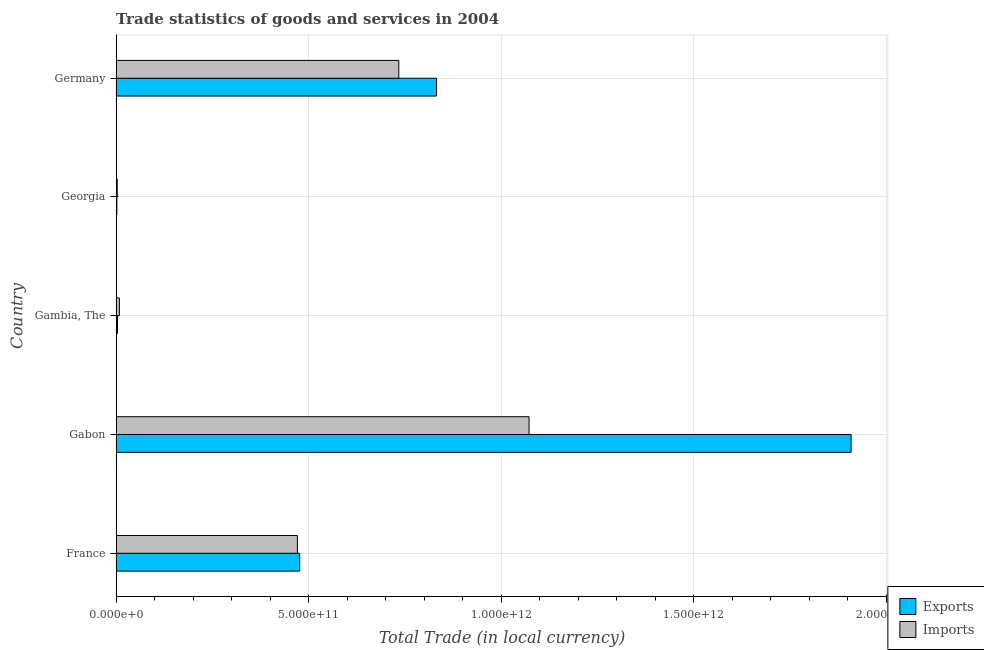Are the number of bars per tick equal to the number of legend labels?
Ensure brevity in your answer.  Yes. What is the label of the 2nd group of bars from the top?
Your answer should be very brief. Georgia. What is the imports of goods and services in Gambia, The?
Your answer should be very brief. 8.47e+09. Across all countries, what is the maximum imports of goods and services?
Offer a terse response. 1.07e+12. Across all countries, what is the minimum imports of goods and services?
Make the answer very short. 2.89e+09. In which country was the export of goods and services maximum?
Offer a terse response. Gabon. In which country was the imports of goods and services minimum?
Provide a succinct answer. Georgia. What is the total export of goods and services in the graph?
Your response must be concise. 3.22e+12. What is the difference between the export of goods and services in Georgia and that in Germany?
Provide a short and direct response. -8.30e+11. What is the difference between the imports of goods and services in Germany and the export of goods and services in France?
Make the answer very short. 2.57e+11. What is the average export of goods and services per country?
Ensure brevity in your answer.  6.44e+11. What is the difference between the imports of goods and services and export of goods and services in France?
Make the answer very short. -6.03e+09. What is the ratio of the export of goods and services in Gabon to that in Georgia?
Make the answer very short. 1007.66. Is the export of goods and services in Gabon less than that in Gambia, The?
Make the answer very short. No. What is the difference between the highest and the second highest export of goods and services?
Ensure brevity in your answer.  1.08e+12. What is the difference between the highest and the lowest export of goods and services?
Your response must be concise. 1.91e+12. What does the 1st bar from the top in France represents?
Your answer should be compact. Imports. What does the 1st bar from the bottom in Gambia, The represents?
Offer a very short reply. Exports. Are all the bars in the graph horizontal?
Provide a short and direct response. Yes. How many countries are there in the graph?
Make the answer very short. 5. What is the difference between two consecutive major ticks on the X-axis?
Provide a succinct answer. 5.00e+11. Does the graph contain any zero values?
Ensure brevity in your answer.  No. Where does the legend appear in the graph?
Give a very brief answer. Bottom right. How many legend labels are there?
Keep it short and to the point. 2. What is the title of the graph?
Keep it short and to the point. Trade statistics of goods and services in 2004. What is the label or title of the X-axis?
Your answer should be compact. Total Trade (in local currency). What is the Total Trade (in local currency) in Exports in France?
Ensure brevity in your answer.  4.77e+11. What is the Total Trade (in local currency) in Imports in France?
Keep it short and to the point. 4.71e+11. What is the Total Trade (in local currency) in Exports in Gabon?
Offer a terse response. 1.91e+12. What is the Total Trade (in local currency) of Imports in Gabon?
Keep it short and to the point. 1.07e+12. What is the Total Trade (in local currency) in Exports in Gambia, The?
Provide a succinct answer. 3.53e+09. What is the Total Trade (in local currency) in Imports in Gambia, The?
Provide a short and direct response. 8.47e+09. What is the Total Trade (in local currency) in Exports in Georgia?
Give a very brief answer. 1.89e+09. What is the Total Trade (in local currency) of Imports in Georgia?
Ensure brevity in your answer.  2.89e+09. What is the Total Trade (in local currency) of Exports in Germany?
Give a very brief answer. 8.32e+11. What is the Total Trade (in local currency) of Imports in Germany?
Provide a succinct answer. 7.34e+11. Across all countries, what is the maximum Total Trade (in local currency) of Exports?
Offer a terse response. 1.91e+12. Across all countries, what is the maximum Total Trade (in local currency) in Imports?
Your response must be concise. 1.07e+12. Across all countries, what is the minimum Total Trade (in local currency) of Exports?
Make the answer very short. 1.89e+09. Across all countries, what is the minimum Total Trade (in local currency) in Imports?
Your answer should be compact. 2.89e+09. What is the total Total Trade (in local currency) of Exports in the graph?
Keep it short and to the point. 3.22e+12. What is the total Total Trade (in local currency) of Imports in the graph?
Ensure brevity in your answer.  2.29e+12. What is the difference between the Total Trade (in local currency) in Exports in France and that in Gabon?
Your answer should be very brief. -1.43e+12. What is the difference between the Total Trade (in local currency) in Imports in France and that in Gabon?
Offer a terse response. -6.02e+11. What is the difference between the Total Trade (in local currency) of Exports in France and that in Gambia, The?
Your response must be concise. 4.73e+11. What is the difference between the Total Trade (in local currency) of Imports in France and that in Gambia, The?
Provide a succinct answer. 4.62e+11. What is the difference between the Total Trade (in local currency) of Exports in France and that in Georgia?
Your answer should be very brief. 4.75e+11. What is the difference between the Total Trade (in local currency) in Imports in France and that in Georgia?
Your response must be concise. 4.68e+11. What is the difference between the Total Trade (in local currency) of Exports in France and that in Germany?
Provide a short and direct response. -3.55e+11. What is the difference between the Total Trade (in local currency) of Imports in France and that in Germany?
Keep it short and to the point. -2.63e+11. What is the difference between the Total Trade (in local currency) of Exports in Gabon and that in Gambia, The?
Your response must be concise. 1.90e+12. What is the difference between the Total Trade (in local currency) of Imports in Gabon and that in Gambia, The?
Your response must be concise. 1.06e+12. What is the difference between the Total Trade (in local currency) in Exports in Gabon and that in Georgia?
Your answer should be very brief. 1.91e+12. What is the difference between the Total Trade (in local currency) of Imports in Gabon and that in Georgia?
Keep it short and to the point. 1.07e+12. What is the difference between the Total Trade (in local currency) of Exports in Gabon and that in Germany?
Your answer should be compact. 1.08e+12. What is the difference between the Total Trade (in local currency) in Imports in Gabon and that in Germany?
Ensure brevity in your answer.  3.38e+11. What is the difference between the Total Trade (in local currency) in Exports in Gambia, The and that in Georgia?
Provide a short and direct response. 1.64e+09. What is the difference between the Total Trade (in local currency) of Imports in Gambia, The and that in Georgia?
Your response must be concise. 5.58e+09. What is the difference between the Total Trade (in local currency) in Exports in Gambia, The and that in Germany?
Your response must be concise. -8.28e+11. What is the difference between the Total Trade (in local currency) of Imports in Gambia, The and that in Germany?
Your answer should be very brief. -7.25e+11. What is the difference between the Total Trade (in local currency) in Exports in Georgia and that in Germany?
Your answer should be very brief. -8.30e+11. What is the difference between the Total Trade (in local currency) in Imports in Georgia and that in Germany?
Provide a succinct answer. -7.31e+11. What is the difference between the Total Trade (in local currency) in Exports in France and the Total Trade (in local currency) in Imports in Gabon?
Offer a very short reply. -5.95e+11. What is the difference between the Total Trade (in local currency) in Exports in France and the Total Trade (in local currency) in Imports in Gambia, The?
Offer a very short reply. 4.68e+11. What is the difference between the Total Trade (in local currency) in Exports in France and the Total Trade (in local currency) in Imports in Georgia?
Provide a succinct answer. 4.74e+11. What is the difference between the Total Trade (in local currency) of Exports in France and the Total Trade (in local currency) of Imports in Germany?
Give a very brief answer. -2.57e+11. What is the difference between the Total Trade (in local currency) in Exports in Gabon and the Total Trade (in local currency) in Imports in Gambia, The?
Ensure brevity in your answer.  1.90e+12. What is the difference between the Total Trade (in local currency) of Exports in Gabon and the Total Trade (in local currency) of Imports in Georgia?
Offer a very short reply. 1.91e+12. What is the difference between the Total Trade (in local currency) of Exports in Gabon and the Total Trade (in local currency) of Imports in Germany?
Provide a short and direct response. 1.17e+12. What is the difference between the Total Trade (in local currency) of Exports in Gambia, The and the Total Trade (in local currency) of Imports in Georgia?
Provide a short and direct response. 6.42e+08. What is the difference between the Total Trade (in local currency) of Exports in Gambia, The and the Total Trade (in local currency) of Imports in Germany?
Provide a short and direct response. -7.30e+11. What is the difference between the Total Trade (in local currency) of Exports in Georgia and the Total Trade (in local currency) of Imports in Germany?
Give a very brief answer. -7.32e+11. What is the average Total Trade (in local currency) in Exports per country?
Keep it short and to the point. 6.44e+11. What is the average Total Trade (in local currency) of Imports per country?
Provide a succinct answer. 4.58e+11. What is the difference between the Total Trade (in local currency) of Exports and Total Trade (in local currency) of Imports in France?
Provide a succinct answer. 6.03e+09. What is the difference between the Total Trade (in local currency) of Exports and Total Trade (in local currency) of Imports in Gabon?
Provide a succinct answer. 8.36e+11. What is the difference between the Total Trade (in local currency) in Exports and Total Trade (in local currency) in Imports in Gambia, The?
Ensure brevity in your answer.  -4.94e+09. What is the difference between the Total Trade (in local currency) of Exports and Total Trade (in local currency) of Imports in Georgia?
Ensure brevity in your answer.  -9.98e+08. What is the difference between the Total Trade (in local currency) in Exports and Total Trade (in local currency) in Imports in Germany?
Your answer should be very brief. 9.80e+1. What is the ratio of the Total Trade (in local currency) in Exports in France to that in Gabon?
Make the answer very short. 0.25. What is the ratio of the Total Trade (in local currency) of Imports in France to that in Gabon?
Offer a very short reply. 0.44. What is the ratio of the Total Trade (in local currency) of Exports in France to that in Gambia, The?
Provide a short and direct response. 134.88. What is the ratio of the Total Trade (in local currency) in Imports in France to that in Gambia, The?
Your answer should be compact. 55.53. What is the ratio of the Total Trade (in local currency) in Exports in France to that in Georgia?
Provide a succinct answer. 251.68. What is the ratio of the Total Trade (in local currency) in Imports in France to that in Georgia?
Make the answer very short. 162.75. What is the ratio of the Total Trade (in local currency) in Exports in France to that in Germany?
Keep it short and to the point. 0.57. What is the ratio of the Total Trade (in local currency) of Imports in France to that in Germany?
Offer a very short reply. 0.64. What is the ratio of the Total Trade (in local currency) of Exports in Gabon to that in Gambia, The?
Give a very brief answer. 540.01. What is the ratio of the Total Trade (in local currency) in Imports in Gabon to that in Gambia, The?
Give a very brief answer. 126.5. What is the ratio of the Total Trade (in local currency) of Exports in Gabon to that in Georgia?
Your response must be concise. 1007.66. What is the ratio of the Total Trade (in local currency) in Imports in Gabon to that in Georgia?
Keep it short and to the point. 370.76. What is the ratio of the Total Trade (in local currency) of Exports in Gabon to that in Germany?
Keep it short and to the point. 2.29. What is the ratio of the Total Trade (in local currency) in Imports in Gabon to that in Germany?
Your response must be concise. 1.46. What is the ratio of the Total Trade (in local currency) in Exports in Gambia, The to that in Georgia?
Give a very brief answer. 1.87. What is the ratio of the Total Trade (in local currency) of Imports in Gambia, The to that in Georgia?
Ensure brevity in your answer.  2.93. What is the ratio of the Total Trade (in local currency) in Exports in Gambia, The to that in Germany?
Your response must be concise. 0. What is the ratio of the Total Trade (in local currency) in Imports in Gambia, The to that in Germany?
Provide a succinct answer. 0.01. What is the ratio of the Total Trade (in local currency) of Exports in Georgia to that in Germany?
Keep it short and to the point. 0. What is the ratio of the Total Trade (in local currency) of Imports in Georgia to that in Germany?
Ensure brevity in your answer.  0. What is the difference between the highest and the second highest Total Trade (in local currency) in Exports?
Your answer should be compact. 1.08e+12. What is the difference between the highest and the second highest Total Trade (in local currency) in Imports?
Ensure brevity in your answer.  3.38e+11. What is the difference between the highest and the lowest Total Trade (in local currency) in Exports?
Your response must be concise. 1.91e+12. What is the difference between the highest and the lowest Total Trade (in local currency) in Imports?
Make the answer very short. 1.07e+12. 